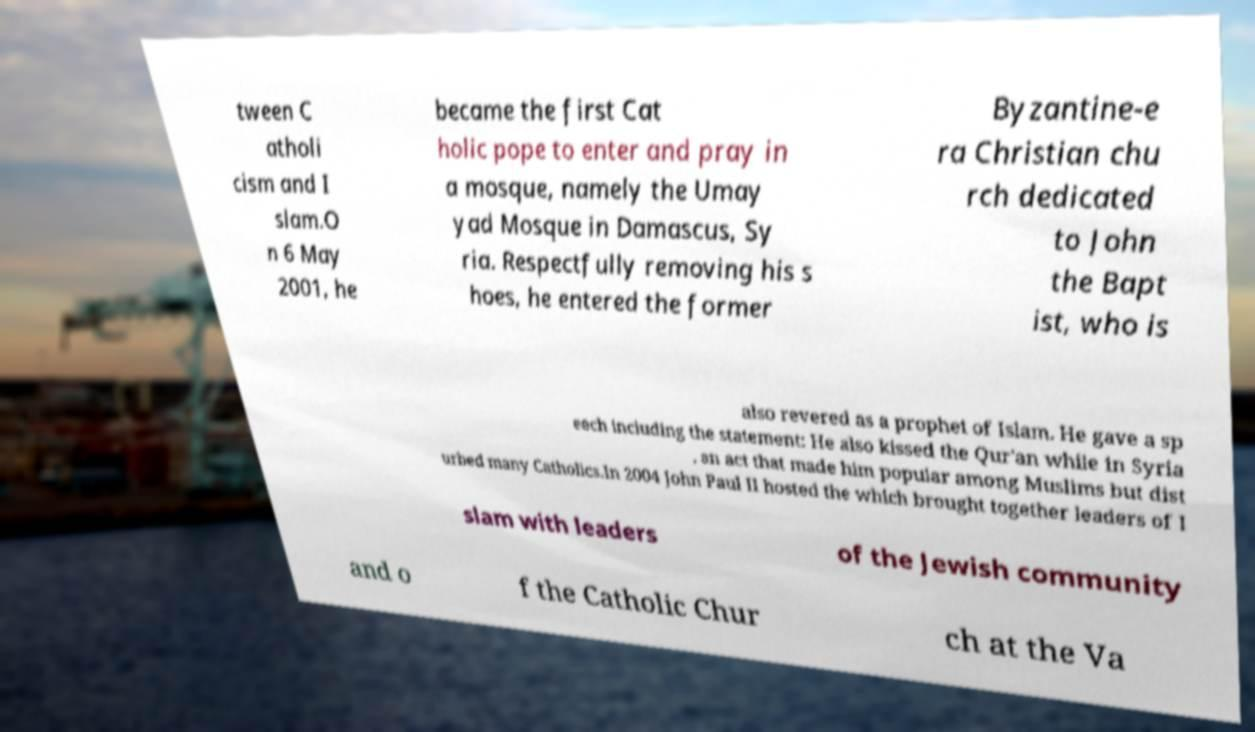For documentation purposes, I need the text within this image transcribed. Could you provide that? tween C atholi cism and I slam.O n 6 May 2001, he became the first Cat holic pope to enter and pray in a mosque, namely the Umay yad Mosque in Damascus, Sy ria. Respectfully removing his s hoes, he entered the former Byzantine-e ra Christian chu rch dedicated to John the Bapt ist, who is also revered as a prophet of Islam. He gave a sp eech including the statement: He also kissed the Qur'an while in Syria , an act that made him popular among Muslims but dist urbed many Catholics.In 2004 John Paul II hosted the which brought together leaders of I slam with leaders of the Jewish community and o f the Catholic Chur ch at the Va 